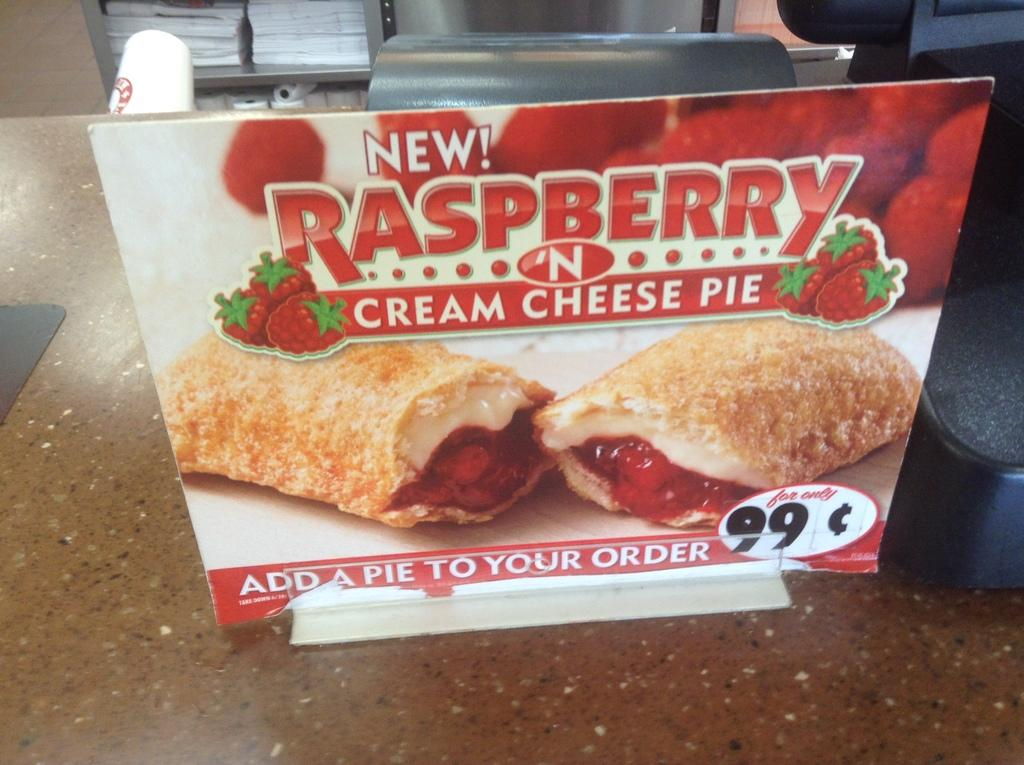What is the main object in the image? There is a board in the image. What colors are used on the board? The board is in red and white colors. What can be seen on the board? Something is written on the board. On what surface is the board placed? The board is on a surface. What can be observed in the background of the image? There are white objects on a rack in the background. How does the engine contribute to the functionality of the board in the image? There is no engine present in the image, so it cannot contribute to the functionality of the board. 